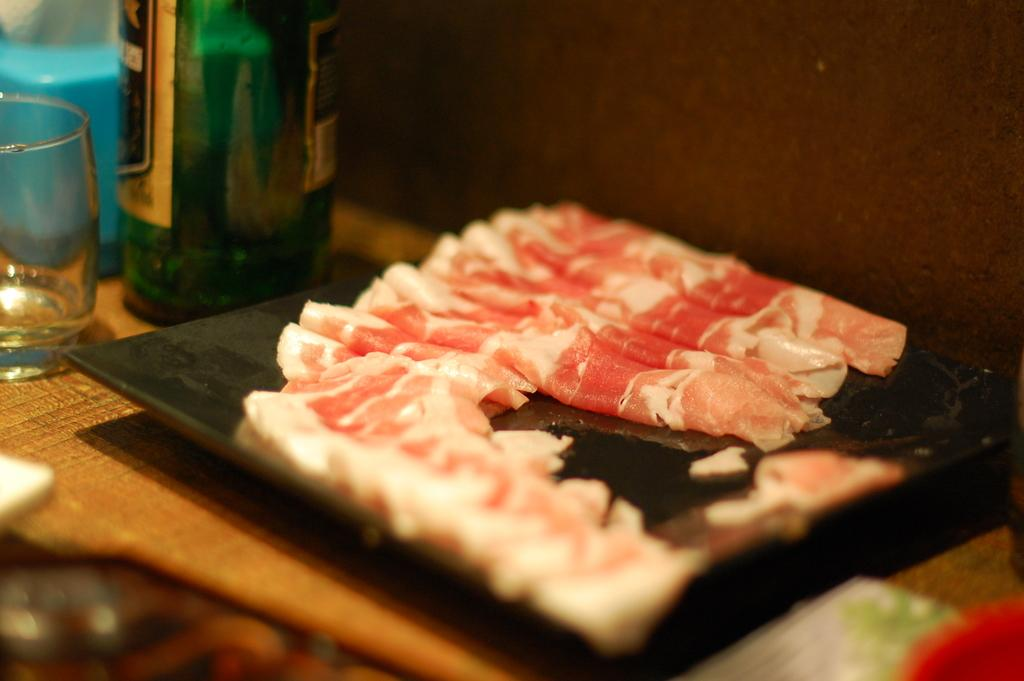What type of furniture is in the image? There is a table in the image. What is on the table? A wine bottle, a glass, and a plate with meat are on the table. Can you describe the wine bottle? The wine bottle is present on the table. What type of substance is the moon made of in the image? There is no moon present in the image. What color is the silverware on the table? There is no silverware mentioned in the image; only a wine bottle, a glass, and a plate with meat are described. 